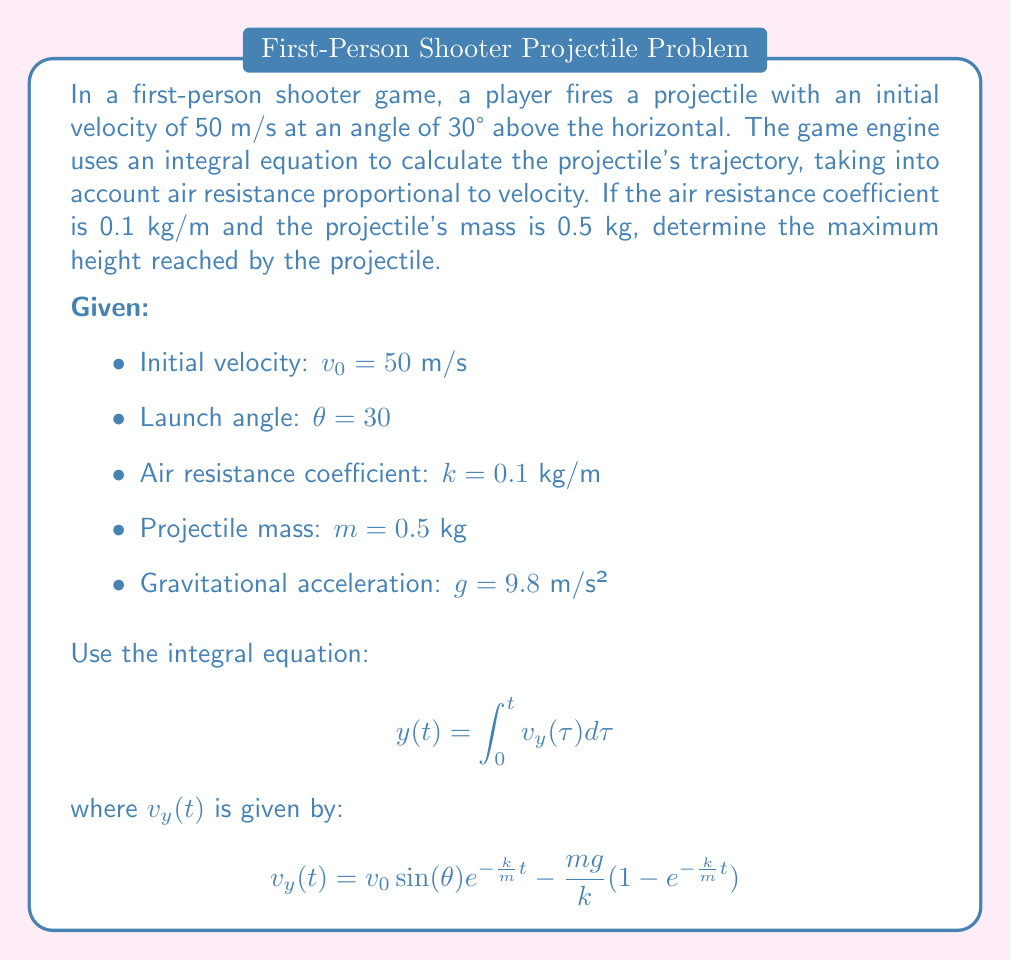Give your solution to this math problem. To find the maximum height, we need to follow these steps:

1) First, we need to find the time $t_{max}$ when the vertical velocity $v_y(t)$ becomes zero:

   $$v_y(t_{max}) = v_0 \sin(\theta) e^{-\frac{k}{m}t_{max}} - \frac{mg}{k}(1 - e^{-\frac{k}{m}t_{max}}) = 0$$

2) Solving this equation numerically (as it's transcendental), we get:
   
   $t_{max} \approx 1.36$ seconds

3) Now, we can use the integral equation to find the maximum height:

   $$y_{max} = y(t_{max}) = \int_0^{t_{max}} v_y(t) dt$$

4) Substituting the expression for $v_y(t)$:

   $$y_{max} = \int_0^{t_{max}} [v_0 \sin(\theta) e^{-\frac{k}{m}t} - \frac{mg}{k}(1 - e^{-\frac{k}{m}t})] dt$$

5) Evaluating this integral:

   $$y_{max} = -\frac{m v_0 \sin(\theta)}{k} (e^{-\frac{k}{m}t_{max}} - 1) - \frac{mg}{k}t_{max} + \frac{m^2g}{k^2}(e^{-\frac{k}{m}t_{max}} - 1)$$

6) Plugging in the values:
   
   $v_0 = 50$ m/s, $\theta = 30°$, $k = 0.1$ kg/m, $m = 0.5$ kg, $g = 9.8$ m/s², $t_{max} \approx 1.36$ s

7) Calculating:

   $$y_{max} \approx 28.7 \text{ meters}$$

Thus, the projectile reaches a maximum height of approximately 28.7 meters.
Answer: 28.7 meters 